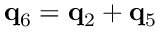Convert formula to latex. <formula><loc_0><loc_0><loc_500><loc_500>{ q } _ { 6 } = { q } _ { 2 } + { q } _ { 5 }</formula> 